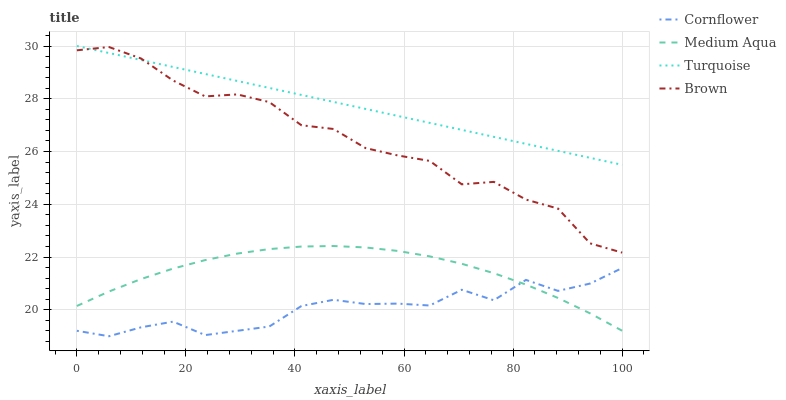Does Cornflower have the minimum area under the curve?
Answer yes or no. Yes. Does Turquoise have the maximum area under the curve?
Answer yes or no. Yes. Does Medium Aqua have the minimum area under the curve?
Answer yes or no. No. Does Medium Aqua have the maximum area under the curve?
Answer yes or no. No. Is Turquoise the smoothest?
Answer yes or no. Yes. Is Brown the roughest?
Answer yes or no. Yes. Is Medium Aqua the smoothest?
Answer yes or no. No. Is Medium Aqua the roughest?
Answer yes or no. No. Does Cornflower have the lowest value?
Answer yes or no. Yes. Does Medium Aqua have the lowest value?
Answer yes or no. No. Does Turquoise have the highest value?
Answer yes or no. Yes. Does Medium Aqua have the highest value?
Answer yes or no. No. Is Medium Aqua less than Brown?
Answer yes or no. Yes. Is Brown greater than Medium Aqua?
Answer yes or no. Yes. Does Cornflower intersect Medium Aqua?
Answer yes or no. Yes. Is Cornflower less than Medium Aqua?
Answer yes or no. No. Is Cornflower greater than Medium Aqua?
Answer yes or no. No. Does Medium Aqua intersect Brown?
Answer yes or no. No. 